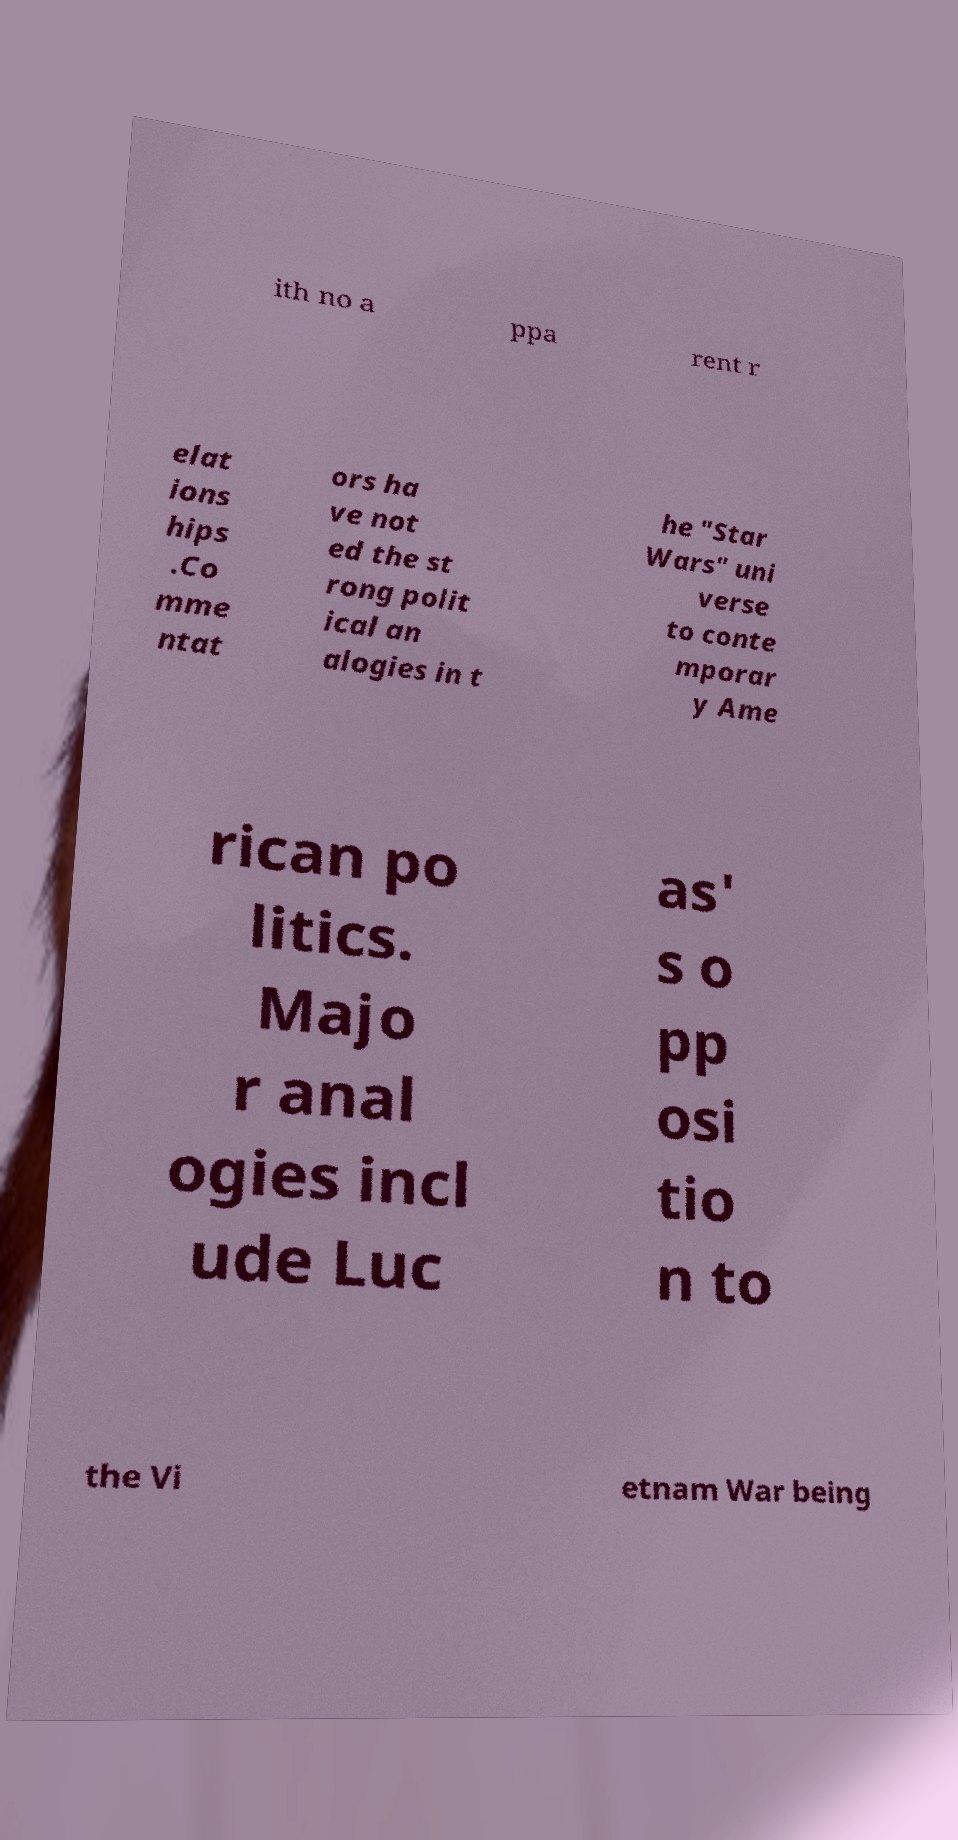What messages or text are displayed in this image? I need them in a readable, typed format. ith no a ppa rent r elat ions hips .Co mme ntat ors ha ve not ed the st rong polit ical an alogies in t he "Star Wars" uni verse to conte mporar y Ame rican po litics. Majo r anal ogies incl ude Luc as' s o pp osi tio n to the Vi etnam War being 